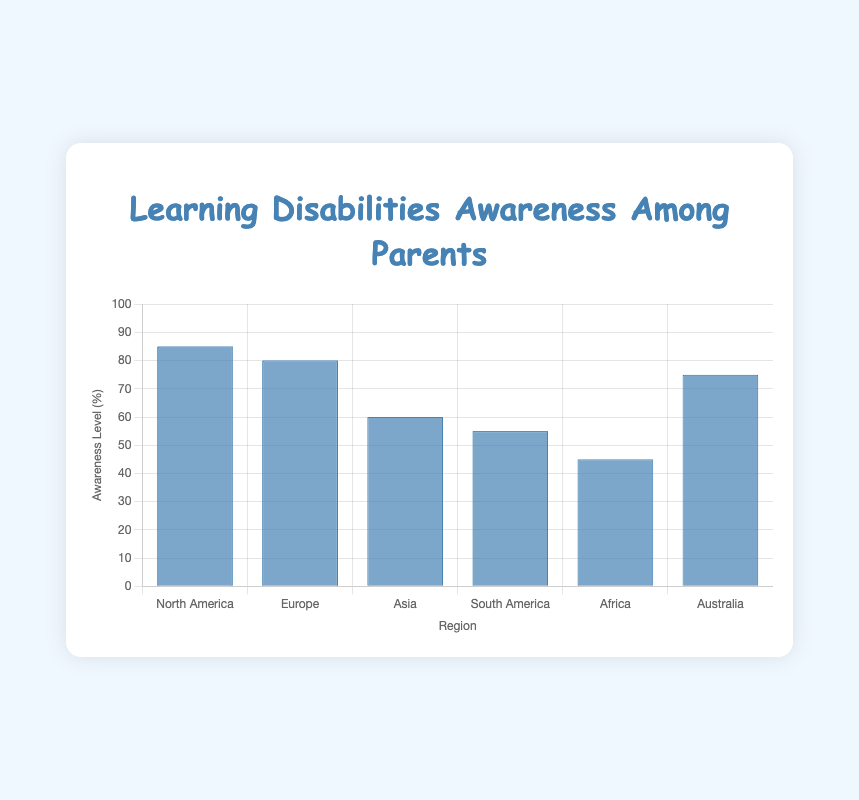Which region has the highest awareness level of learning disabilities among parents? The region with the highest awareness level will have the tallest bar in the bar chart. North America has the tallest bar, indicating the highest awareness level of 85%.
Answer: North America Which region has the lowest awareness level? The region with the lowest awareness level will have the shortest bar in the bar chart. Africa has the shortest bar, indicating the lowest awareness level of 45%.
Answer: Africa What is the difference in awareness levels between North America and Africa? To find the difference, subtract the awareness level percentage of Africa from that of North America (85% - 45%).
Answer: 40% How many regions have an awareness level of 75% or higher? Look at the regions and count the ones with bars at 75% or above: North America (85%), Europe (80%), and Australia (75%). There are 3 such regions.
Answer: 3 How much higher is the awareness level in Europe compared to South America? Subtract the awareness level percentage of South America from Europe (80% - 55%).
Answer: 25% Which regions have an awareness level between 50% and 80%? Look at the bars and identify the regions within this range: South America (55%), Asia (60%), and Australia (75%).
Answer: South America, Asia, Australia What is the average awareness level across all regions? Sum the awareness levels and divide by the number of regions: (85 + 80 + 60 + 55 + 45 + 75) / 6 = 66.67.
Answer: 66.67% Rank the regions from highest to lowest awareness levels. Order the regions based on the height of their bars: North America (85%), Europe (80%), Australia (75%), Asia (60%), South America (55%), Africa (45%).
Answer: North America, Europe, Australia, Asia, South America, Africa What is the total awareness percentage of North America and Europe combined? Add the awareness levels of North America and Europe (85% + 80%).
Answer: 165% If the average awareness level is increased by 5%, what will the new average be? First, calculate the current average (66.67%). Then add 5% to it (66.67 + 5). The new average is 71.67%.
Answer: 71.67% 